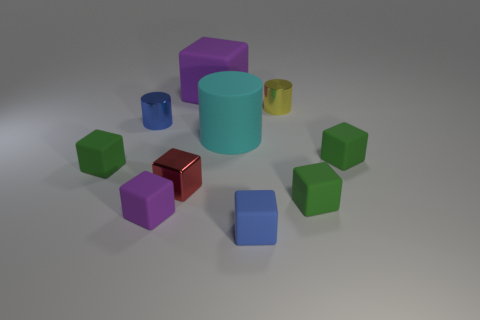Subtract all tiny red cubes. How many cubes are left? 6 Subtract all blue cylinders. How many cylinders are left? 2 Subtract all cylinders. How many objects are left? 7 Subtract 3 blocks. How many blocks are left? 4 Add 7 cyan metallic things. How many cyan metallic things exist? 7 Subtract 0 cyan spheres. How many objects are left? 10 Subtract all purple blocks. Subtract all blue balls. How many blocks are left? 5 Subtract all yellow cylinders. How many blue blocks are left? 1 Subtract all big cylinders. Subtract all small yellow things. How many objects are left? 8 Add 9 large cyan matte cylinders. How many large cyan matte cylinders are left? 10 